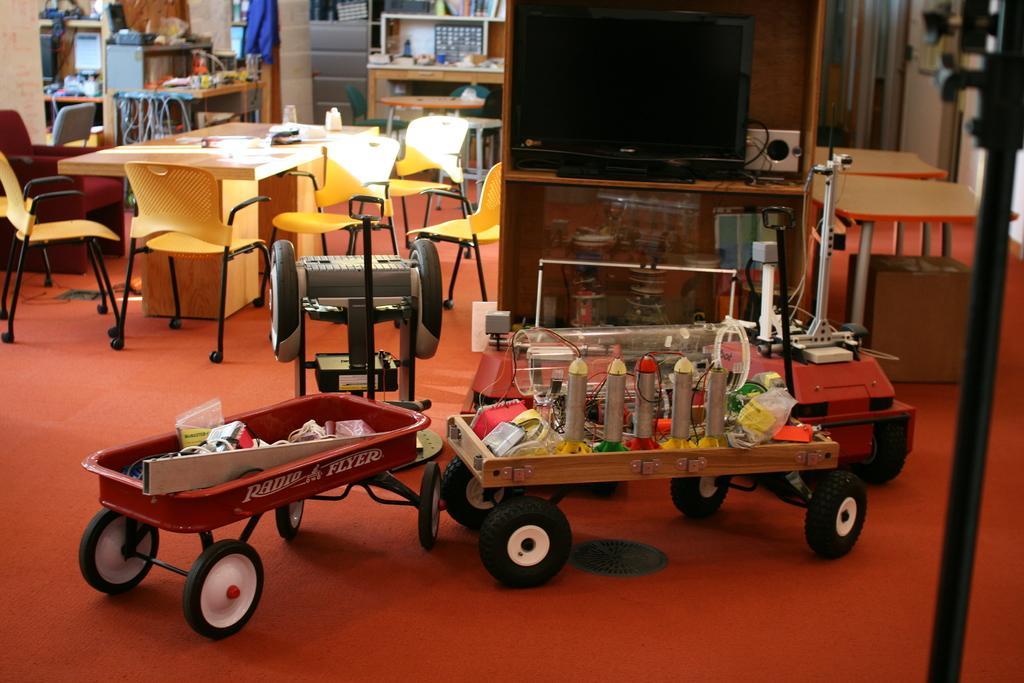Could you give a brief overview of what you see in this image? In this image there is a toy vehicle. At the left side there are few chairs and tables. At the right side there is a cabin having a screen in it. Beside there are two tables. At the top left there are few shelves having some items in it. 